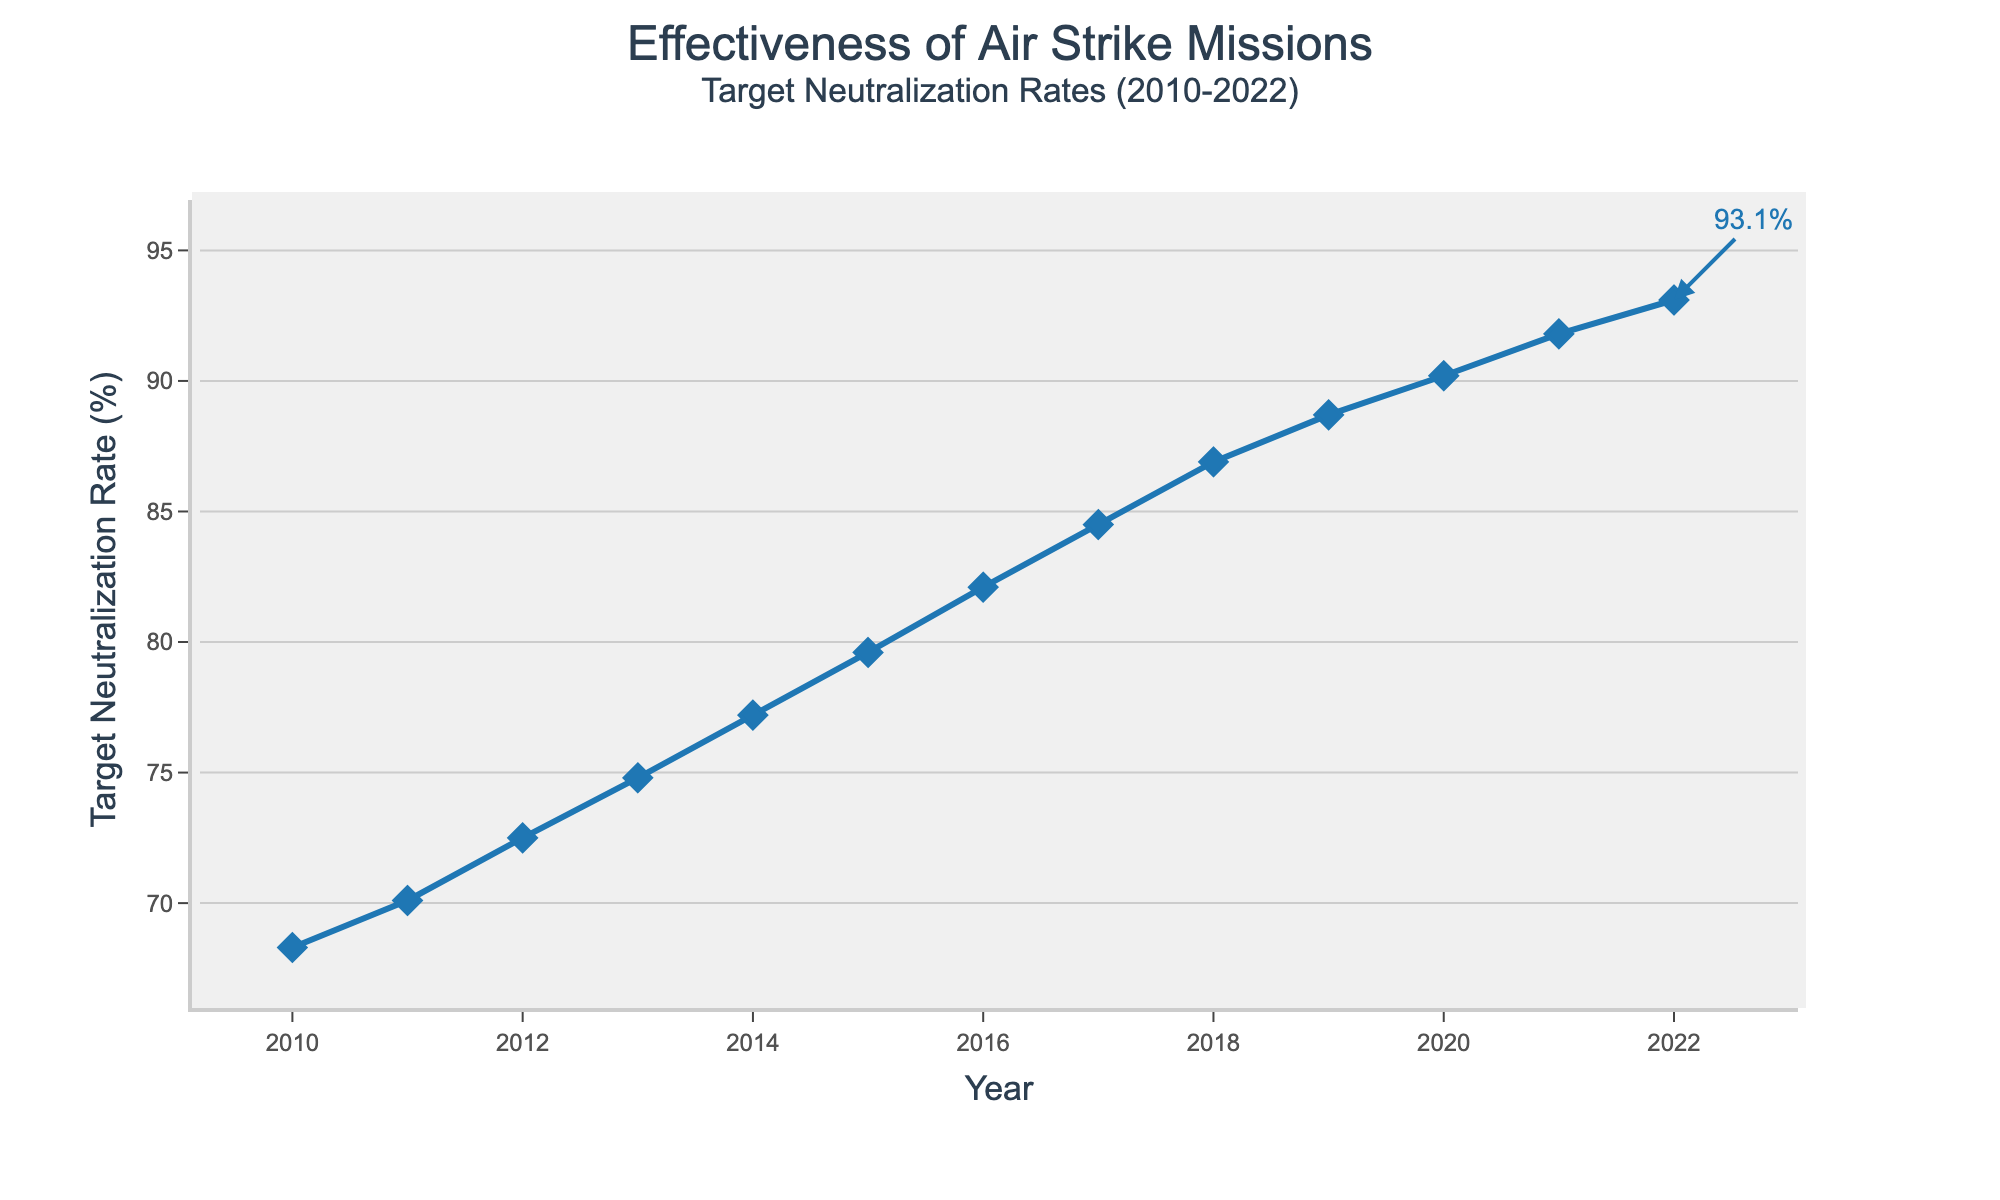What's the median value of the Target Neutralization Rate from 2010 to 2022? To find the median, we need to order the target neutralization rates from smallest to largest and find the middle value. The ordered values are: 68.3, 70.1, 72.5, 74.8, 77.2, 79.6, 82.1, 84.5, 86.9, 88.7, 90.2, 91.8, 93.1. With 13 data points, the median is the 7th value.
Answer: 82.1 How much did the Target Neutralization Rate increase from 2010 to 2022? The increase is found by subtracting the rate in 2010 from the rate in 2022. Therefore, 93.1% (2022) - 68.3% (2010) = 24.8%.
Answer: 24.8% Which year had the largest increase in Target Neutralization Rate compared to the previous year? To determine this, we find the year-to-year differences: 2011-2010=1.8, 2012-2011=2.4, 2013-2012=2.3, 2014-2013=2.4, 2015-2014=2.4, 2016-2015=2.5, 2017-2016=2.4, 2018-2017=2.4, 2019-2018=1.8, 2020-2019=1.5, 2021-2020=1.6, 2022-2021=1.3. The largest difference is 2016-2015.
Answer: 2016 From the provided data, which year had the lowest Target Neutralization Rate? The lowest value from the data provided is 68.3%, which is in the year 2010.
Answer: 2010 What was the average Target Neutralization Rate from 2010 to 2022? To find the average, sum all rates and divide by the number of years: (68.3 + 70.1 + 72.5 + 74.8 + 77.2 + 79.6 + 82.1 + 84.5 + 86.9 + 88.7 + 90.2 + 91.8 + 93.1) / 13 = 82.3%.
Answer: 82.3% Did the Target Neutralization Rate ever decrease between consecutive years? By visually inspecting the line chart, we see a continuous upward trend without any dips, meaning the rate never decreased.
Answer: No Describe the color and shape used to indicate the Target Neutralization Rate in the figure. The Target Neutralization Rate is represented by a blue line with diamond-shaped markers.
Answer: Blue line with diamonds What is annotated in the figure, and where is it placed? The annotation "93.1%" is placed near the point for the year 2022, indicating the Target Neutralization Rate for that particular year.
Answer: "93.1%" near 2022 